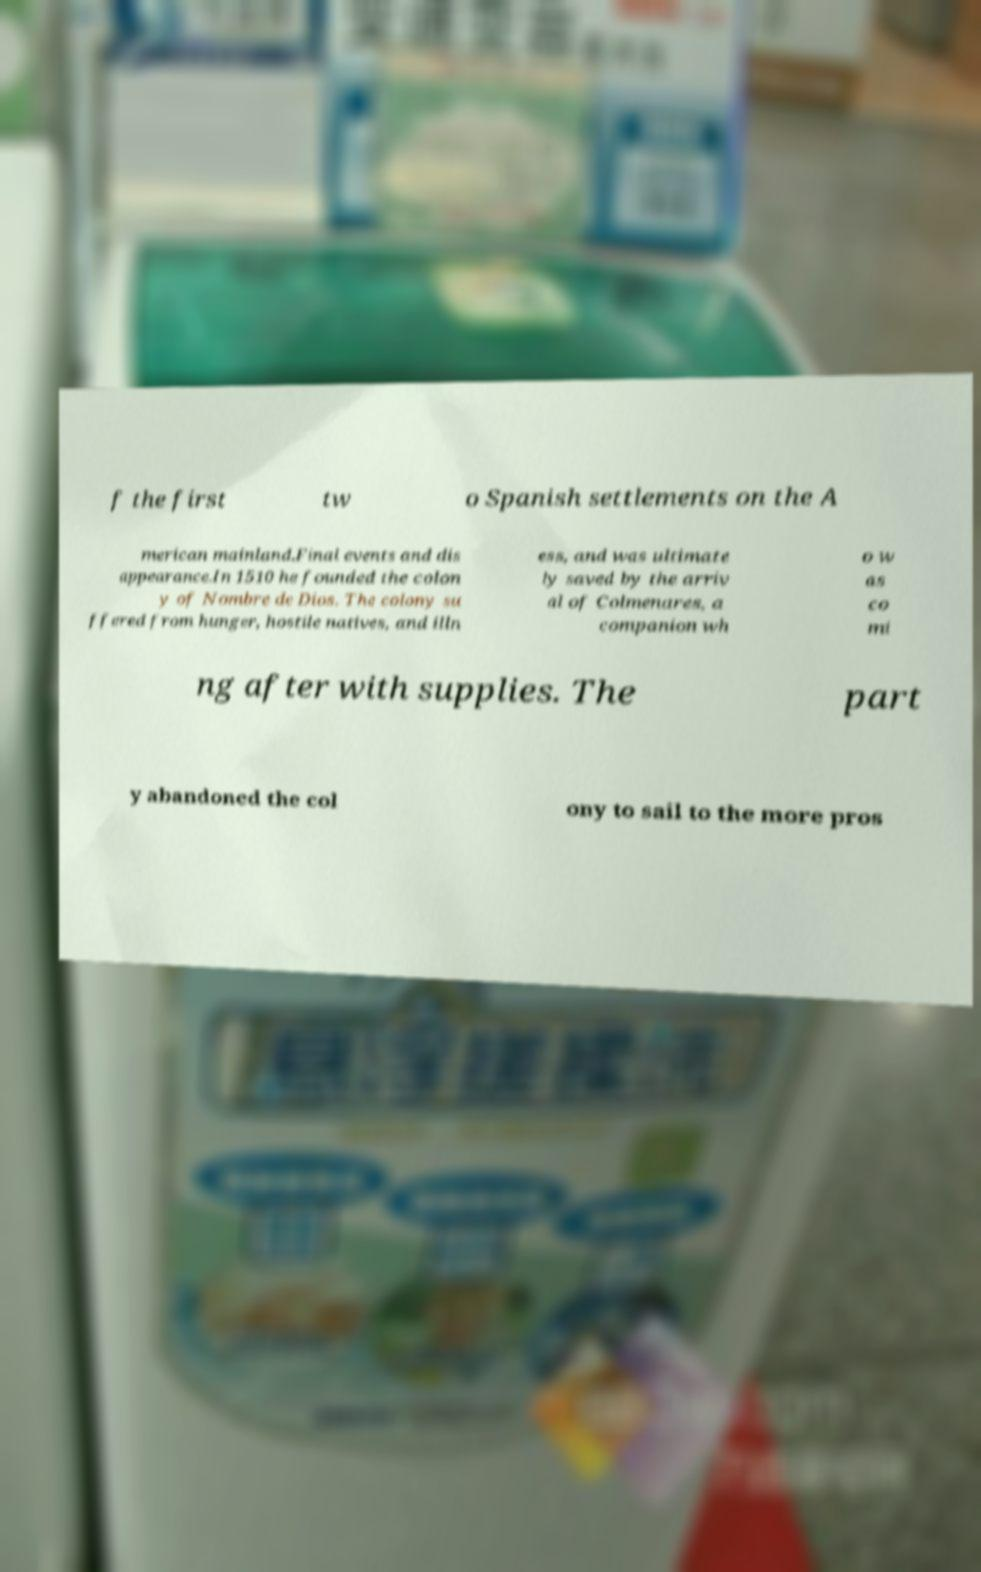There's text embedded in this image that I need extracted. Can you transcribe it verbatim? f the first tw o Spanish settlements on the A merican mainland.Final events and dis appearance.In 1510 he founded the colon y of Nombre de Dios. The colony su ffered from hunger, hostile natives, and illn ess, and was ultimate ly saved by the arriv al of Colmenares, a companion wh o w as co mi ng after with supplies. The part y abandoned the col ony to sail to the more pros 